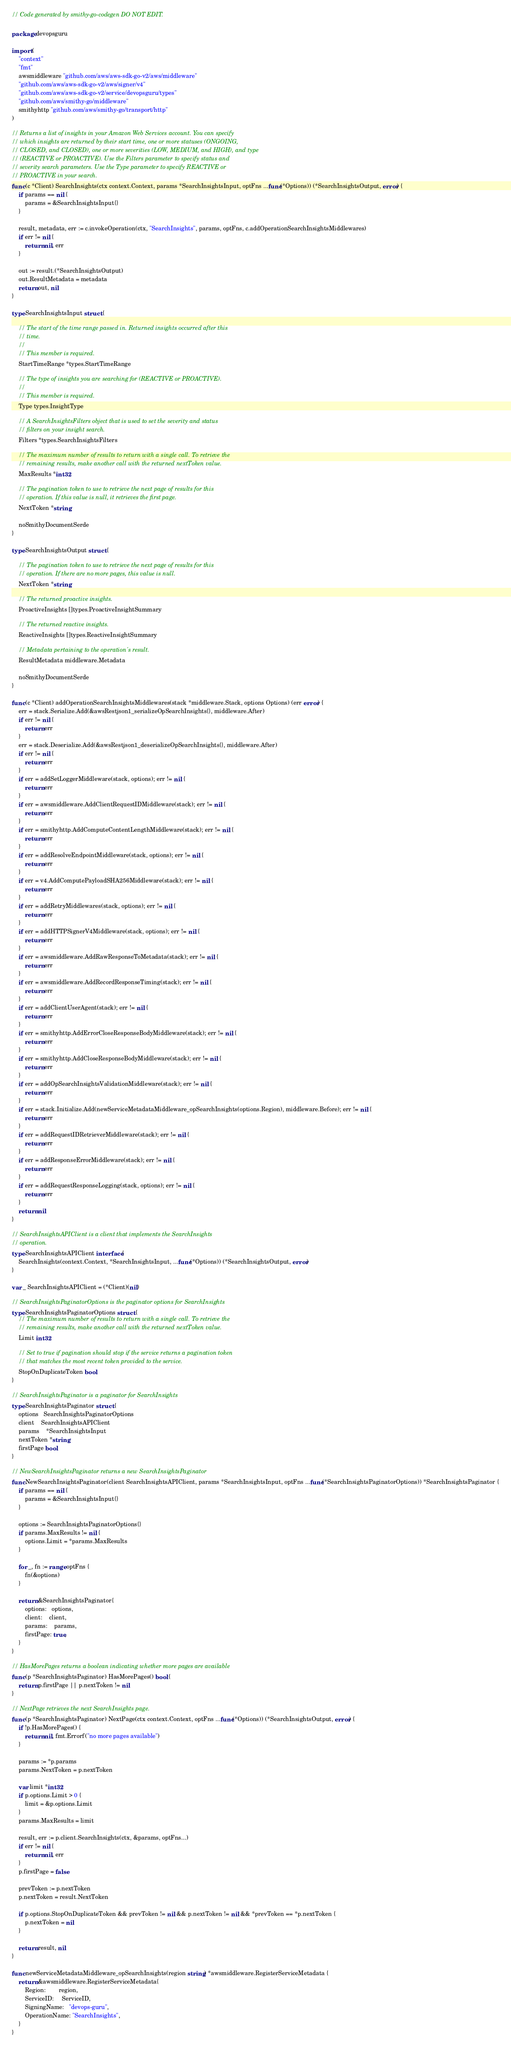Convert code to text. <code><loc_0><loc_0><loc_500><loc_500><_Go_>// Code generated by smithy-go-codegen DO NOT EDIT.

package devopsguru

import (
	"context"
	"fmt"
	awsmiddleware "github.com/aws/aws-sdk-go-v2/aws/middleware"
	"github.com/aws/aws-sdk-go-v2/aws/signer/v4"
	"github.com/aws/aws-sdk-go-v2/service/devopsguru/types"
	"github.com/aws/smithy-go/middleware"
	smithyhttp "github.com/aws/smithy-go/transport/http"
)

// Returns a list of insights in your Amazon Web Services account. You can specify
// which insights are returned by their start time, one or more statuses (ONGOING,
// CLOSED, and CLOSED), one or more severities (LOW, MEDIUM, and HIGH), and type
// (REACTIVE or PROACTIVE). Use the Filters parameter to specify status and
// severity search parameters. Use the Type parameter to specify REACTIVE or
// PROACTIVE in your search.
func (c *Client) SearchInsights(ctx context.Context, params *SearchInsightsInput, optFns ...func(*Options)) (*SearchInsightsOutput, error) {
	if params == nil {
		params = &SearchInsightsInput{}
	}

	result, metadata, err := c.invokeOperation(ctx, "SearchInsights", params, optFns, c.addOperationSearchInsightsMiddlewares)
	if err != nil {
		return nil, err
	}

	out := result.(*SearchInsightsOutput)
	out.ResultMetadata = metadata
	return out, nil
}

type SearchInsightsInput struct {

	// The start of the time range passed in. Returned insights occurred after this
	// time.
	//
	// This member is required.
	StartTimeRange *types.StartTimeRange

	// The type of insights you are searching for (REACTIVE or PROACTIVE).
	//
	// This member is required.
	Type types.InsightType

	// A SearchInsightsFilters object that is used to set the severity and status
	// filters on your insight search.
	Filters *types.SearchInsightsFilters

	// The maximum number of results to return with a single call. To retrieve the
	// remaining results, make another call with the returned nextToken value.
	MaxResults *int32

	// The pagination token to use to retrieve the next page of results for this
	// operation. If this value is null, it retrieves the first page.
	NextToken *string

	noSmithyDocumentSerde
}

type SearchInsightsOutput struct {

	// The pagination token to use to retrieve the next page of results for this
	// operation. If there are no more pages, this value is null.
	NextToken *string

	// The returned proactive insights.
	ProactiveInsights []types.ProactiveInsightSummary

	// The returned reactive insights.
	ReactiveInsights []types.ReactiveInsightSummary

	// Metadata pertaining to the operation's result.
	ResultMetadata middleware.Metadata

	noSmithyDocumentSerde
}

func (c *Client) addOperationSearchInsightsMiddlewares(stack *middleware.Stack, options Options) (err error) {
	err = stack.Serialize.Add(&awsRestjson1_serializeOpSearchInsights{}, middleware.After)
	if err != nil {
		return err
	}
	err = stack.Deserialize.Add(&awsRestjson1_deserializeOpSearchInsights{}, middleware.After)
	if err != nil {
		return err
	}
	if err = addSetLoggerMiddleware(stack, options); err != nil {
		return err
	}
	if err = awsmiddleware.AddClientRequestIDMiddleware(stack); err != nil {
		return err
	}
	if err = smithyhttp.AddComputeContentLengthMiddleware(stack); err != nil {
		return err
	}
	if err = addResolveEndpointMiddleware(stack, options); err != nil {
		return err
	}
	if err = v4.AddComputePayloadSHA256Middleware(stack); err != nil {
		return err
	}
	if err = addRetryMiddlewares(stack, options); err != nil {
		return err
	}
	if err = addHTTPSignerV4Middleware(stack, options); err != nil {
		return err
	}
	if err = awsmiddleware.AddRawResponseToMetadata(stack); err != nil {
		return err
	}
	if err = awsmiddleware.AddRecordResponseTiming(stack); err != nil {
		return err
	}
	if err = addClientUserAgent(stack); err != nil {
		return err
	}
	if err = smithyhttp.AddErrorCloseResponseBodyMiddleware(stack); err != nil {
		return err
	}
	if err = smithyhttp.AddCloseResponseBodyMiddleware(stack); err != nil {
		return err
	}
	if err = addOpSearchInsightsValidationMiddleware(stack); err != nil {
		return err
	}
	if err = stack.Initialize.Add(newServiceMetadataMiddleware_opSearchInsights(options.Region), middleware.Before); err != nil {
		return err
	}
	if err = addRequestIDRetrieverMiddleware(stack); err != nil {
		return err
	}
	if err = addResponseErrorMiddleware(stack); err != nil {
		return err
	}
	if err = addRequestResponseLogging(stack, options); err != nil {
		return err
	}
	return nil
}

// SearchInsightsAPIClient is a client that implements the SearchInsights
// operation.
type SearchInsightsAPIClient interface {
	SearchInsights(context.Context, *SearchInsightsInput, ...func(*Options)) (*SearchInsightsOutput, error)
}

var _ SearchInsightsAPIClient = (*Client)(nil)

// SearchInsightsPaginatorOptions is the paginator options for SearchInsights
type SearchInsightsPaginatorOptions struct {
	// The maximum number of results to return with a single call. To retrieve the
	// remaining results, make another call with the returned nextToken value.
	Limit int32

	// Set to true if pagination should stop if the service returns a pagination token
	// that matches the most recent token provided to the service.
	StopOnDuplicateToken bool
}

// SearchInsightsPaginator is a paginator for SearchInsights
type SearchInsightsPaginator struct {
	options   SearchInsightsPaginatorOptions
	client    SearchInsightsAPIClient
	params    *SearchInsightsInput
	nextToken *string
	firstPage bool
}

// NewSearchInsightsPaginator returns a new SearchInsightsPaginator
func NewSearchInsightsPaginator(client SearchInsightsAPIClient, params *SearchInsightsInput, optFns ...func(*SearchInsightsPaginatorOptions)) *SearchInsightsPaginator {
	if params == nil {
		params = &SearchInsightsInput{}
	}

	options := SearchInsightsPaginatorOptions{}
	if params.MaxResults != nil {
		options.Limit = *params.MaxResults
	}

	for _, fn := range optFns {
		fn(&options)
	}

	return &SearchInsightsPaginator{
		options:   options,
		client:    client,
		params:    params,
		firstPage: true,
	}
}

// HasMorePages returns a boolean indicating whether more pages are available
func (p *SearchInsightsPaginator) HasMorePages() bool {
	return p.firstPage || p.nextToken != nil
}

// NextPage retrieves the next SearchInsights page.
func (p *SearchInsightsPaginator) NextPage(ctx context.Context, optFns ...func(*Options)) (*SearchInsightsOutput, error) {
	if !p.HasMorePages() {
		return nil, fmt.Errorf("no more pages available")
	}

	params := *p.params
	params.NextToken = p.nextToken

	var limit *int32
	if p.options.Limit > 0 {
		limit = &p.options.Limit
	}
	params.MaxResults = limit

	result, err := p.client.SearchInsights(ctx, &params, optFns...)
	if err != nil {
		return nil, err
	}
	p.firstPage = false

	prevToken := p.nextToken
	p.nextToken = result.NextToken

	if p.options.StopOnDuplicateToken && prevToken != nil && p.nextToken != nil && *prevToken == *p.nextToken {
		p.nextToken = nil
	}

	return result, nil
}

func newServiceMetadataMiddleware_opSearchInsights(region string) *awsmiddleware.RegisterServiceMetadata {
	return &awsmiddleware.RegisterServiceMetadata{
		Region:        region,
		ServiceID:     ServiceID,
		SigningName:   "devops-guru",
		OperationName: "SearchInsights",
	}
}
</code> 